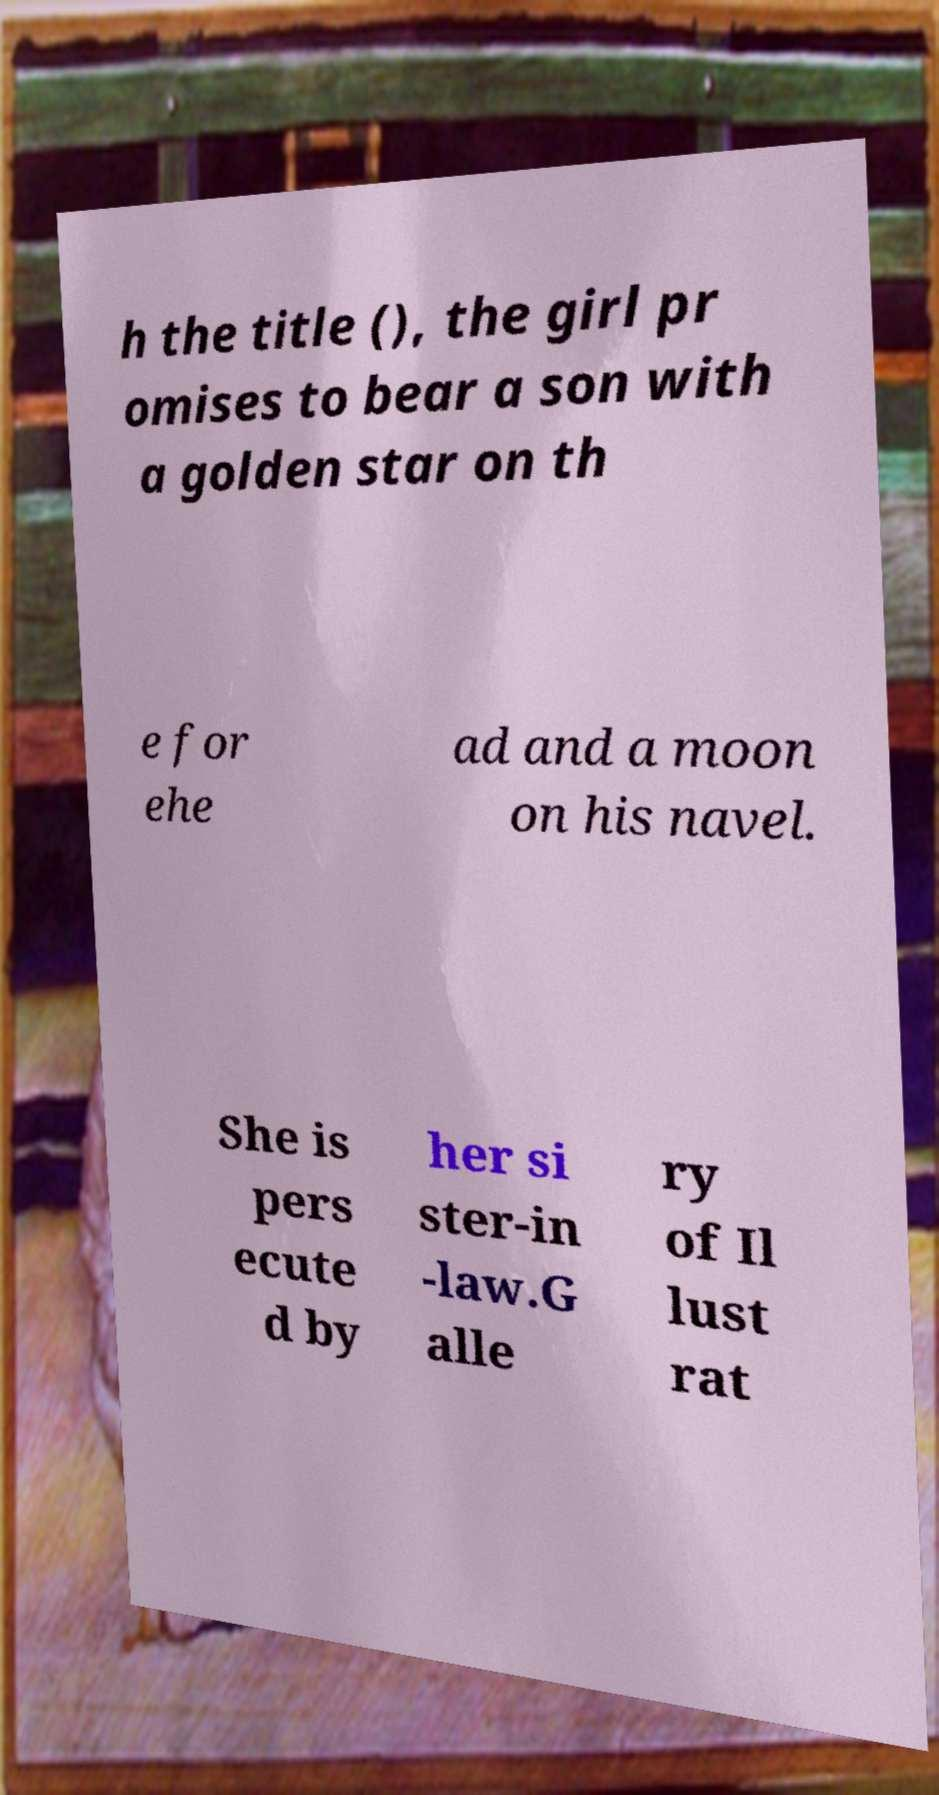For documentation purposes, I need the text within this image transcribed. Could you provide that? h the title (), the girl pr omises to bear a son with a golden star on th e for ehe ad and a moon on his navel. She is pers ecute d by her si ster-in -law.G alle ry of Il lust rat 